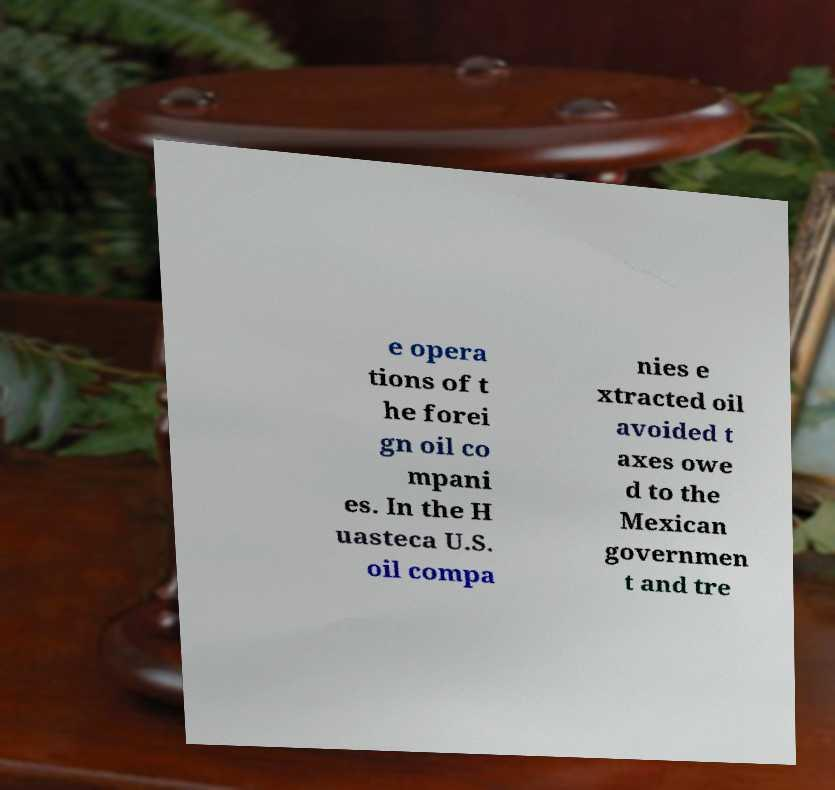For documentation purposes, I need the text within this image transcribed. Could you provide that? e opera tions of t he forei gn oil co mpani es. In the H uasteca U.S. oil compa nies e xtracted oil avoided t axes owe d to the Mexican governmen t and tre 